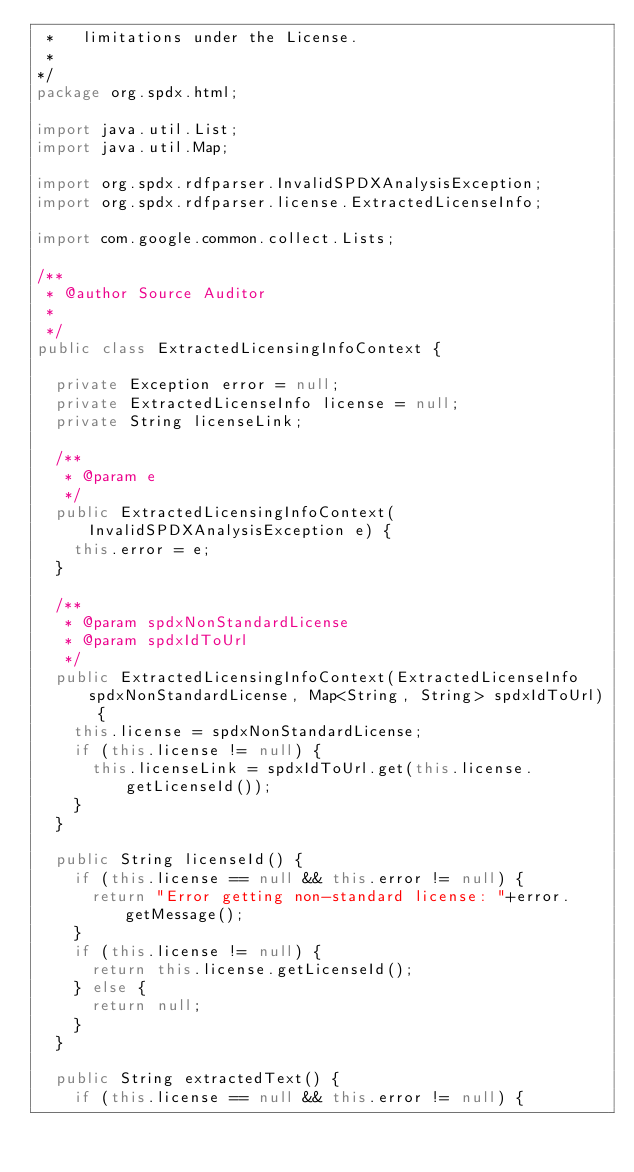Convert code to text. <code><loc_0><loc_0><loc_500><loc_500><_Java_> *   limitations under the License.
 *
*/
package org.spdx.html;

import java.util.List;
import java.util.Map;

import org.spdx.rdfparser.InvalidSPDXAnalysisException;
import org.spdx.rdfparser.license.ExtractedLicenseInfo;

import com.google.common.collect.Lists;

/**
 * @author Source Auditor
 *
 */
public class ExtractedLicensingInfoContext {

	private Exception error = null;
	private ExtractedLicenseInfo license = null;
	private String licenseLink;
	
	/**
	 * @param e
	 */
	public ExtractedLicensingInfoContext(InvalidSPDXAnalysisException e) {
		this.error = e;
	}

	/**
	 * @param spdxNonStandardLicense
	 * @param spdxIdToUrl 
	 */
	public ExtractedLicensingInfoContext(ExtractedLicenseInfo spdxNonStandardLicense, Map<String, String> spdxIdToUrl) {
		this.license = spdxNonStandardLicense;
		if (this.license != null) {
			this.licenseLink = spdxIdToUrl.get(this.license.getLicenseId());
		}	
	}
	
	public String licenseId() {
		if (this.license == null && this.error != null) {
			return "Error getting non-standard license: "+error.getMessage();
		}
		if (this.license != null) {
			return this.license.getLicenseId();
		} else {
			return null;
		}
	}
	
	public String extractedText() {
		if (this.license == null && this.error != null) {</code> 